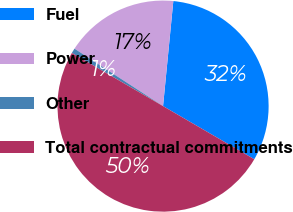Convert chart. <chart><loc_0><loc_0><loc_500><loc_500><pie_chart><fcel>Fuel<fcel>Power<fcel>Other<fcel>Total contractual commitments<nl><fcel>31.84%<fcel>17.39%<fcel>0.76%<fcel>50.0%<nl></chart> 